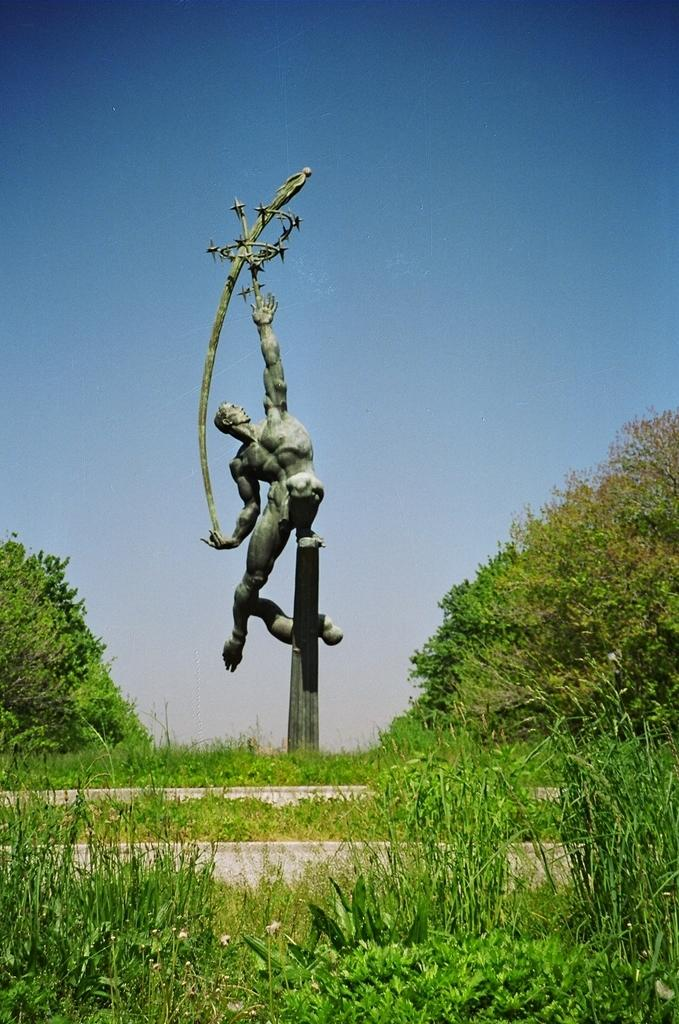What is the main subject in the center of the picture? There is a sculpture in the center of the picture. What can be seen in the foreground of the image? There are plants, a staircase, and grass in the foreground. What is visible in the background of the image? There are trees in the background. How would you describe the weather based on the image? The sky is sunny, suggesting a clear and pleasant day. What type of addition problem can be solved using the sculpture in the image? There is no addition problem present in the image, as it features a sculpture and various elements of nature. 